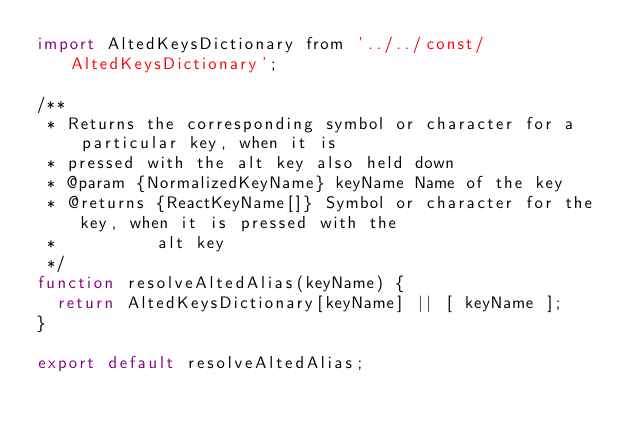Convert code to text. <code><loc_0><loc_0><loc_500><loc_500><_JavaScript_>import AltedKeysDictionary from '../../const/AltedKeysDictionary';

/**
 * Returns the corresponding symbol or character for a particular key, when it is
 * pressed with the alt key also held down
 * @param {NormalizedKeyName} keyName Name of the key
 * @returns {ReactKeyName[]} Symbol or character for the key, when it is pressed with the
 *          alt key
 */
function resolveAltedAlias(keyName) {
  return AltedKeysDictionary[keyName] || [ keyName ];
}

export default resolveAltedAlias;
</code> 